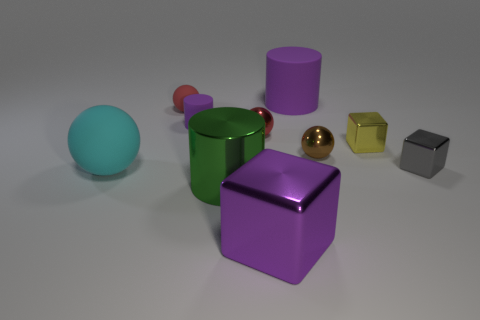Subtract all yellow spheres. Subtract all cyan blocks. How many spheres are left? 4 Subtract all cylinders. How many objects are left? 7 Subtract all tiny gray blocks. Subtract all tiny metallic balls. How many objects are left? 7 Add 4 big purple metallic objects. How many big purple metallic objects are left? 5 Add 6 red matte objects. How many red matte objects exist? 7 Subtract 0 blue cubes. How many objects are left? 10 